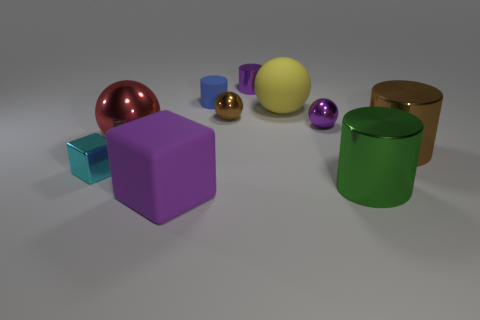Subtract 2 cylinders. How many cylinders are left? 2 Subtract all spheres. How many objects are left? 6 Subtract 0 blue blocks. How many objects are left? 10 Subtract all big metal cylinders. Subtract all red balls. How many objects are left? 7 Add 3 cyan metallic objects. How many cyan metallic objects are left? 4 Add 8 small cyan metallic blocks. How many small cyan metallic blocks exist? 9 